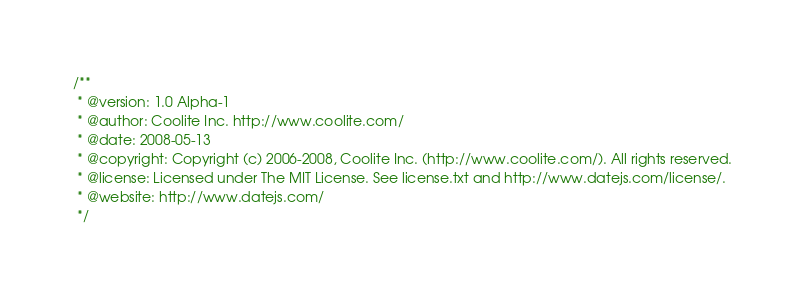Convert code to text. <code><loc_0><loc_0><loc_500><loc_500><_JavaScript_>/**
 * @version: 1.0 Alpha-1
 * @author: Coolite Inc. http://www.coolite.com/
 * @date: 2008-05-13
 * @copyright: Copyright (c) 2006-2008, Coolite Inc. (http://www.coolite.com/). All rights reserved.
 * @license: Licensed under The MIT License. See license.txt and http://www.datejs.com/license/. 
 * @website: http://www.datejs.com/
 */</code> 